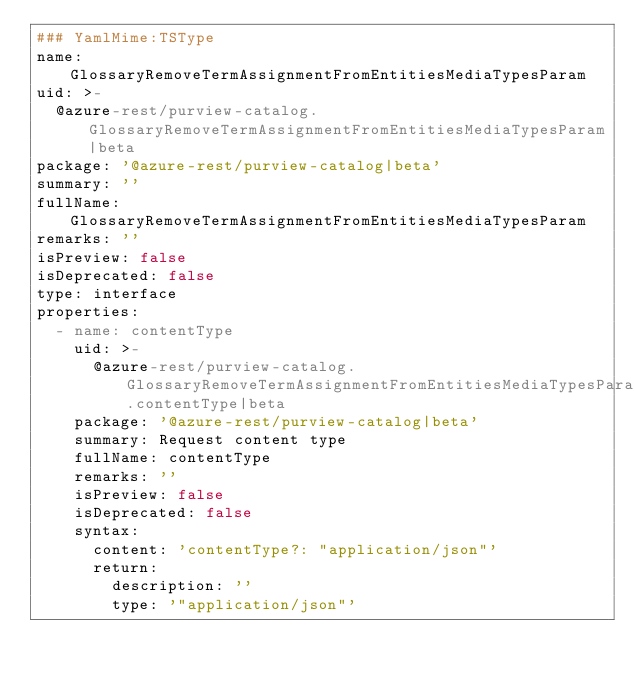<code> <loc_0><loc_0><loc_500><loc_500><_YAML_>### YamlMime:TSType
name: GlossaryRemoveTermAssignmentFromEntitiesMediaTypesParam
uid: >-
  @azure-rest/purview-catalog.GlossaryRemoveTermAssignmentFromEntitiesMediaTypesParam|beta
package: '@azure-rest/purview-catalog|beta'
summary: ''
fullName: GlossaryRemoveTermAssignmentFromEntitiesMediaTypesParam
remarks: ''
isPreview: false
isDeprecated: false
type: interface
properties:
  - name: contentType
    uid: >-
      @azure-rest/purview-catalog.GlossaryRemoveTermAssignmentFromEntitiesMediaTypesParam.contentType|beta
    package: '@azure-rest/purview-catalog|beta'
    summary: Request content type
    fullName: contentType
    remarks: ''
    isPreview: false
    isDeprecated: false
    syntax:
      content: 'contentType?: "application/json"'
      return:
        description: ''
        type: '"application/json"'
</code> 